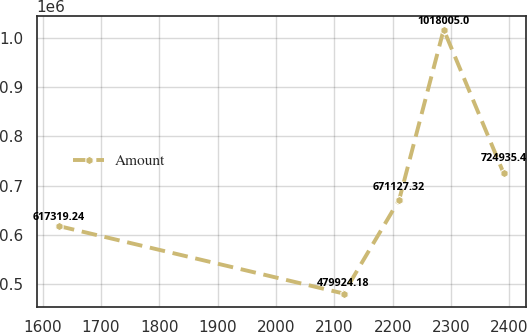Convert chart. <chart><loc_0><loc_0><loc_500><loc_500><line_chart><ecel><fcel>Amount<nl><fcel>1628.13<fcel>617319<nl><fcel>2115.71<fcel>479924<nl><fcel>2211.03<fcel>671127<nl><fcel>2287.22<fcel>1.018e+06<nl><fcel>2390.03<fcel>724935<nl></chart> 